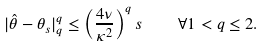Convert formula to latex. <formula><loc_0><loc_0><loc_500><loc_500>| \hat { \theta } - \theta _ { s } | _ { q } ^ { q } \leq \left ( \frac { 4 \nu } { \kappa ^ { 2 } } \right ) ^ { q } s \quad \forall 1 < q \leq 2 .</formula> 